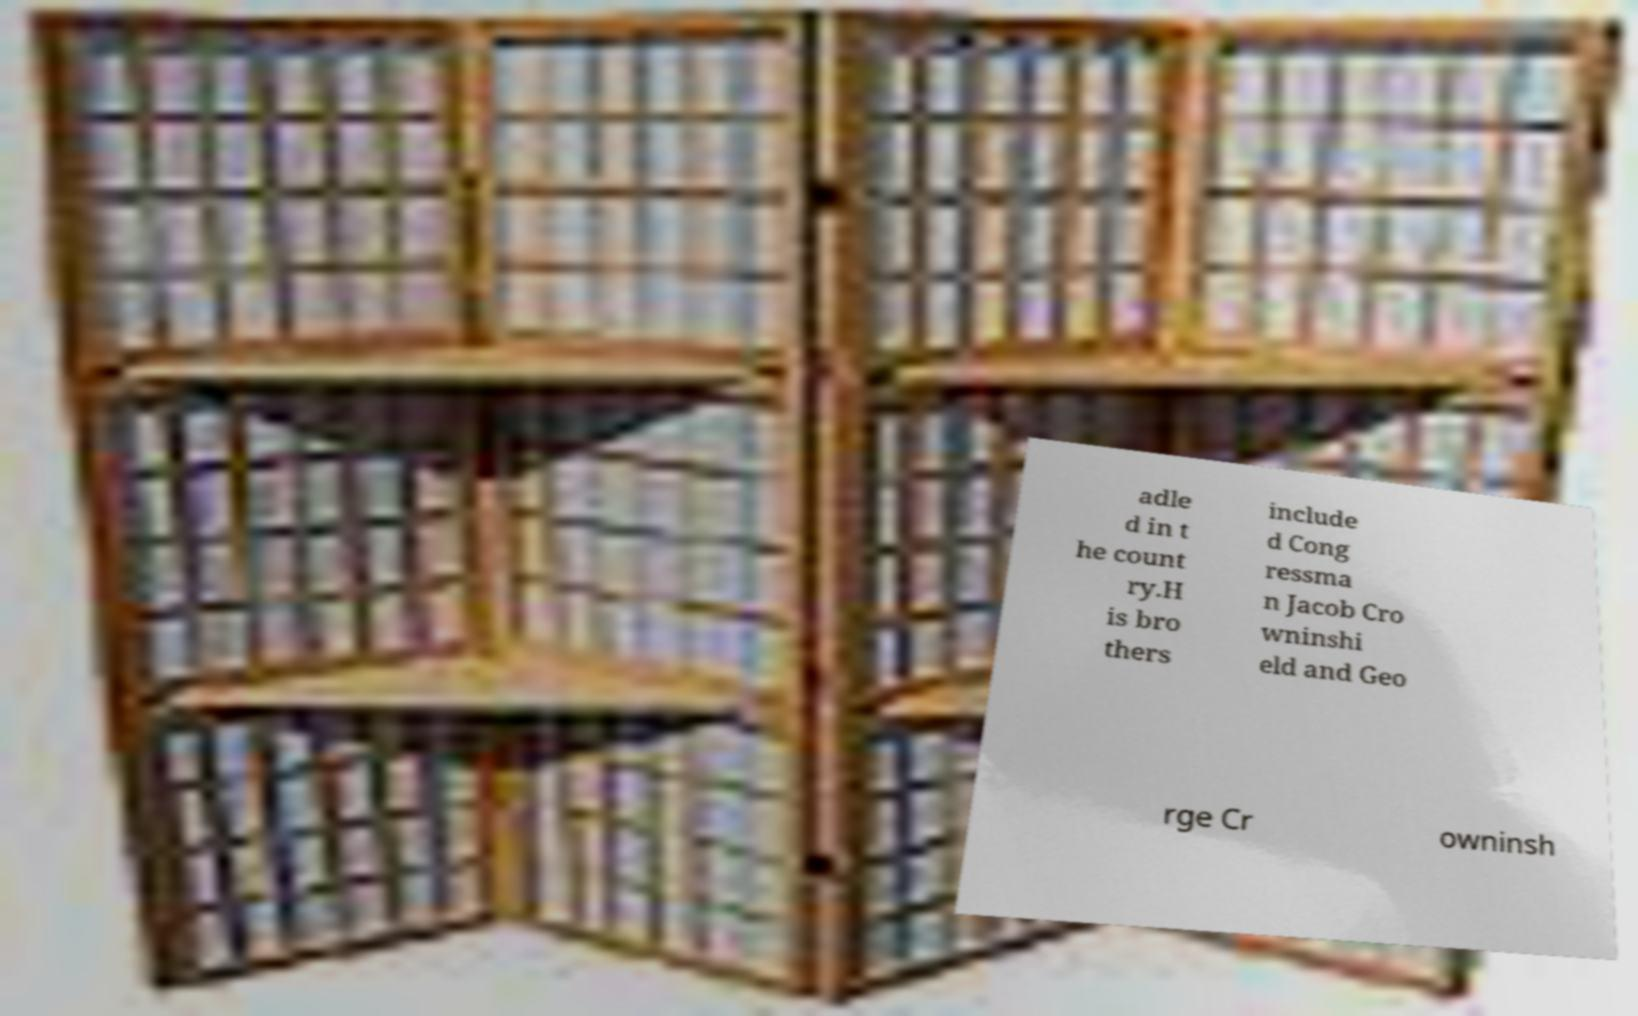I need the written content from this picture converted into text. Can you do that? adle d in t he count ry.H is bro thers include d Cong ressma n Jacob Cro wninshi eld and Geo rge Cr owninsh 